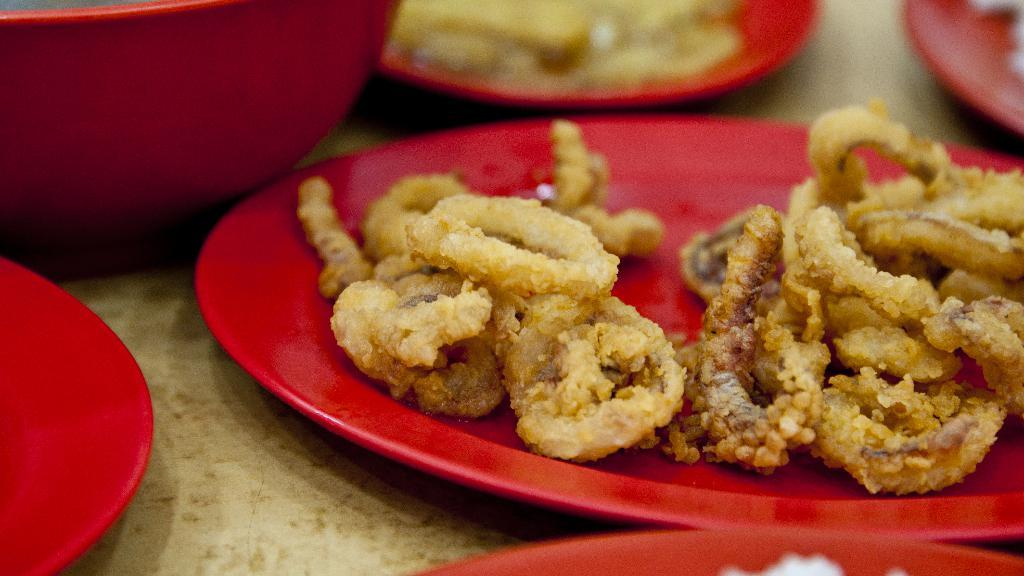What color is the bowl that is visible in the image? There is a red color bowl in the image. What else can be seen on the table besides the bowl? There are plates in the image. What is on the plates that are visible in the image? The plates contain food items. Where are the bowl and plates located in the image? The bowl and plates are placed on a table. What type of noise can be heard coming from the bowl in the image? There is no noise coming from the bowl in the image; it is a still image. 